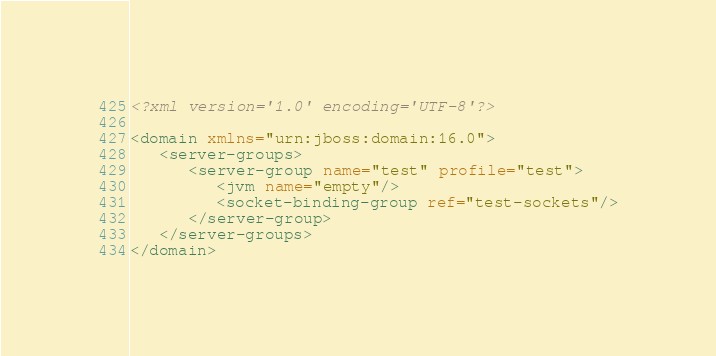<code> <loc_0><loc_0><loc_500><loc_500><_XML_><?xml version='1.0' encoding='UTF-8'?>

<domain xmlns="urn:jboss:domain:16.0">
   <server-groups>
	  <server-group name="test" profile="test">
         <jvm name="empty"/>
         <socket-binding-group ref="test-sockets"/>
 	  </server-group>
   </server-groups>	  
</domain>
</code> 